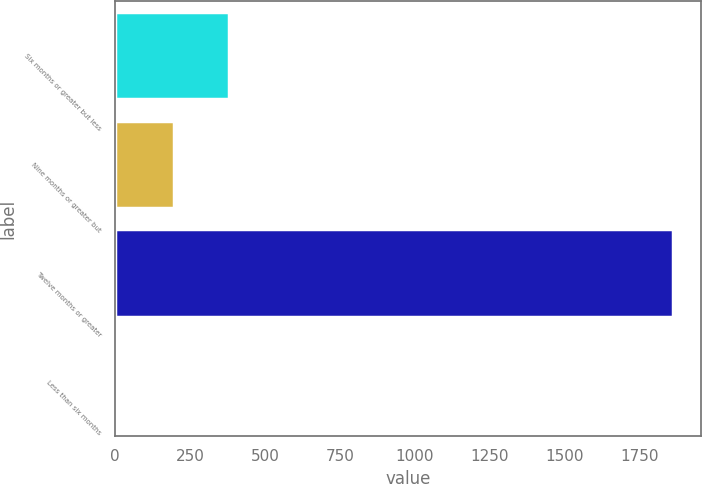Convert chart. <chart><loc_0><loc_0><loc_500><loc_500><bar_chart><fcel>Six months or greater but less<fcel>Nine months or greater but<fcel>Twelve months or greater<fcel>Less than six months<nl><fcel>380.6<fcel>195.3<fcel>1863<fcel>10<nl></chart> 